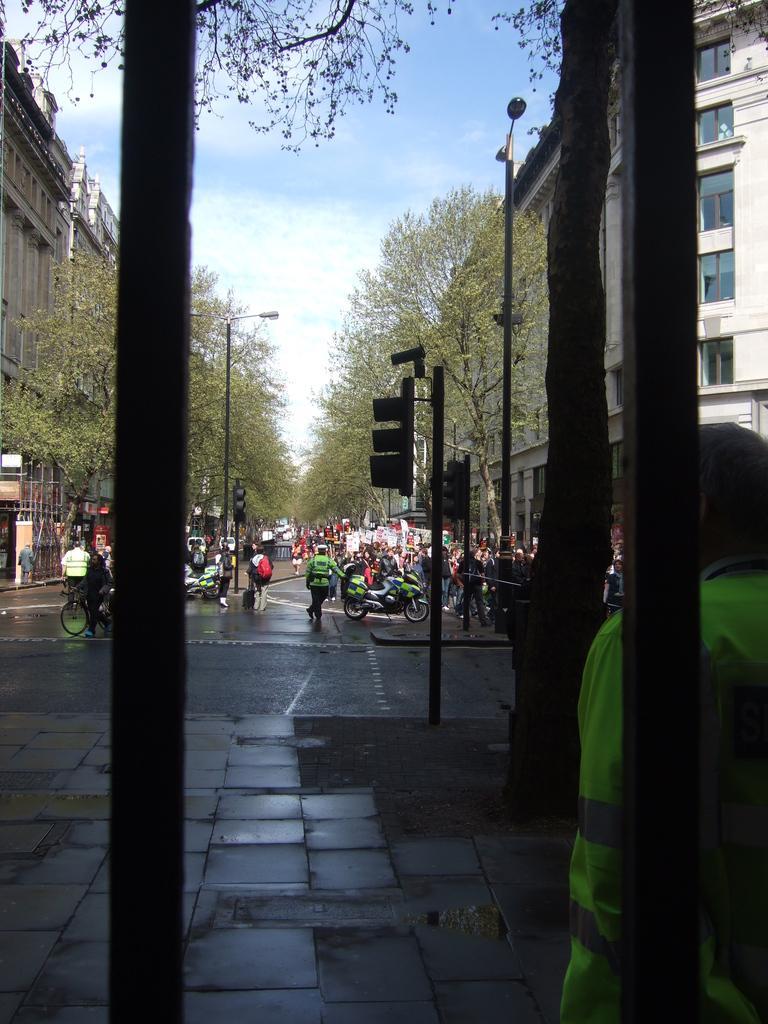Can you describe this image briefly? In this image I can see few poles, a person standing, the road, few vehicles and few persons on the road, few traffic signals, few trees and few buildings on both sides of the road. In the background I can see the sky. 